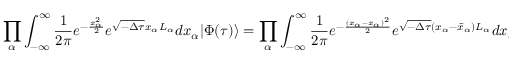Convert formula to latex. <formula><loc_0><loc_0><loc_500><loc_500>\prod _ { \alpha } \int _ { - \infty } ^ { \infty } \frac { 1 } { 2 \pi } e ^ { - \frac { x _ { \alpha } ^ { 2 } } { 2 } } e ^ { \sqrt { - \Delta \tau } x _ { \alpha } L _ { \alpha } } d x _ { \alpha } | \Phi ( \tau ) \rangle = \prod _ { \alpha } \int _ { - \infty } ^ { \infty } \frac { 1 } { 2 \pi } e ^ { - \frac { ( x _ { \alpha } - \bar { x } _ { \alpha } ) ^ { 2 } } { 2 } } e ^ { \sqrt { - \Delta \tau } ( x _ { \alpha } - \bar { x } _ { \alpha } ) L _ { \alpha } } d x _ { \alpha } | \Phi ( \tau ) \rangle ,</formula> 